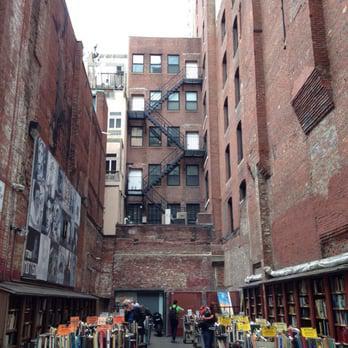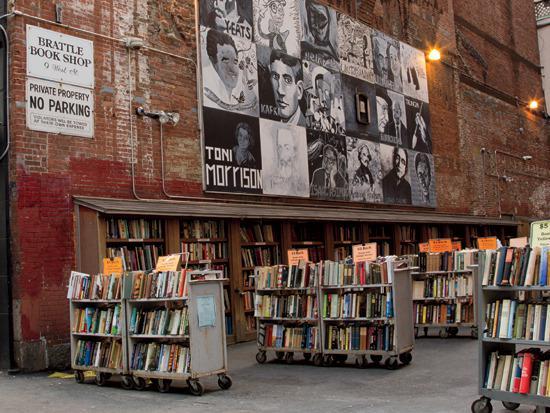The first image is the image on the left, the second image is the image on the right. Assess this claim about the two images: "A light sits on a pole on the street.". Correct or not? Answer yes or no. No. The first image is the image on the left, the second image is the image on the right. Analyze the images presented: Is the assertion "stairs can be seen in the image on the left" valid? Answer yes or no. Yes. 